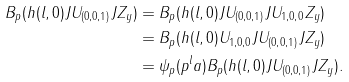<formula> <loc_0><loc_0><loc_500><loc_500>B _ { p } ( h ( l , 0 ) J U _ { ( 0 , 0 , 1 ) } J Z _ { y } ) & = B _ { p } ( h ( l , 0 ) J U _ { ( 0 , 0 , 1 ) } J U _ { 1 , 0 , 0 } Z _ { y } ) \\ & = B _ { p } ( h ( l , 0 ) U _ { 1 , 0 , 0 } J U _ { ( 0 , 0 , 1 ) } J Z _ { y } ) \\ & = \psi _ { p } ( p ^ { l } a ) B _ { p } ( h ( l , 0 ) J U _ { ( 0 , 0 , 1 ) } J Z _ { y } ) .</formula> 